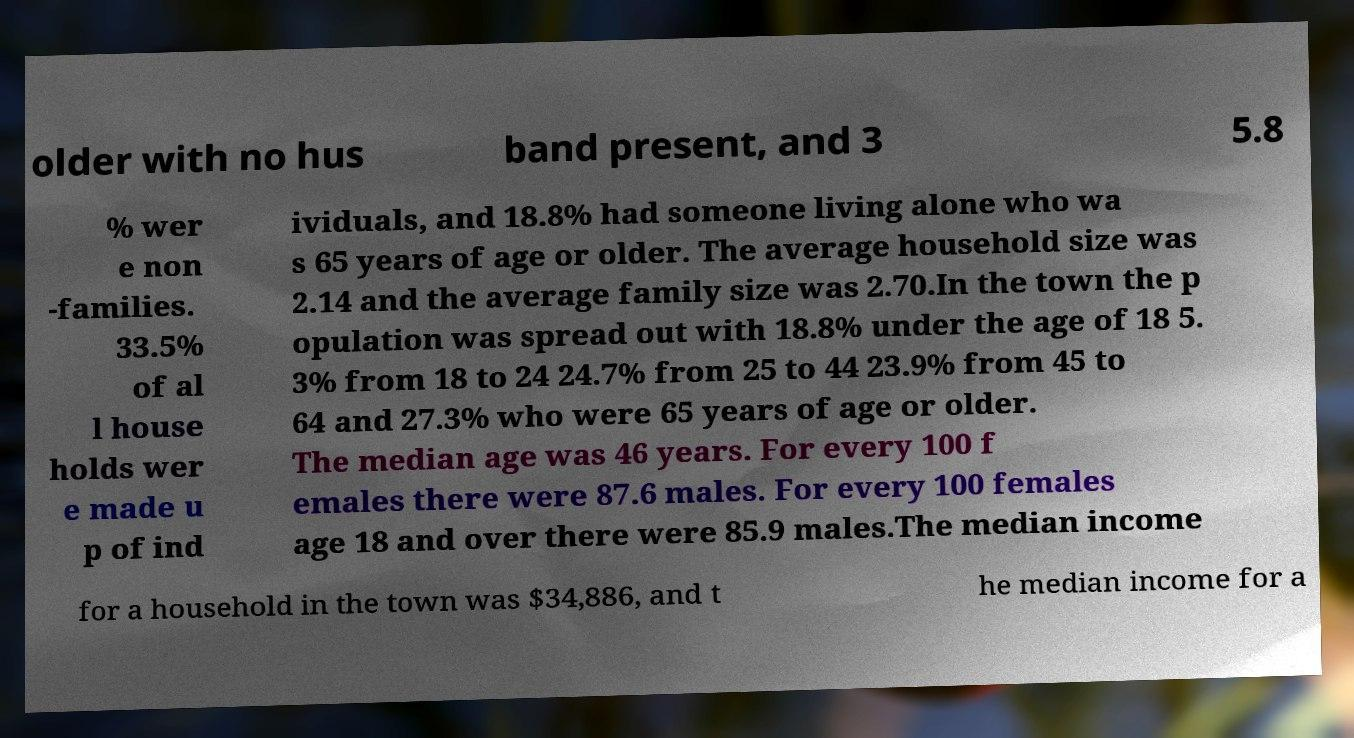There's text embedded in this image that I need extracted. Can you transcribe it verbatim? older with no hus band present, and 3 5.8 % wer e non -families. 33.5% of al l house holds wer e made u p of ind ividuals, and 18.8% had someone living alone who wa s 65 years of age or older. The average household size was 2.14 and the average family size was 2.70.In the town the p opulation was spread out with 18.8% under the age of 18 5. 3% from 18 to 24 24.7% from 25 to 44 23.9% from 45 to 64 and 27.3% who were 65 years of age or older. The median age was 46 years. For every 100 f emales there were 87.6 males. For every 100 females age 18 and over there were 85.9 males.The median income for a household in the town was $34,886, and t he median income for a 